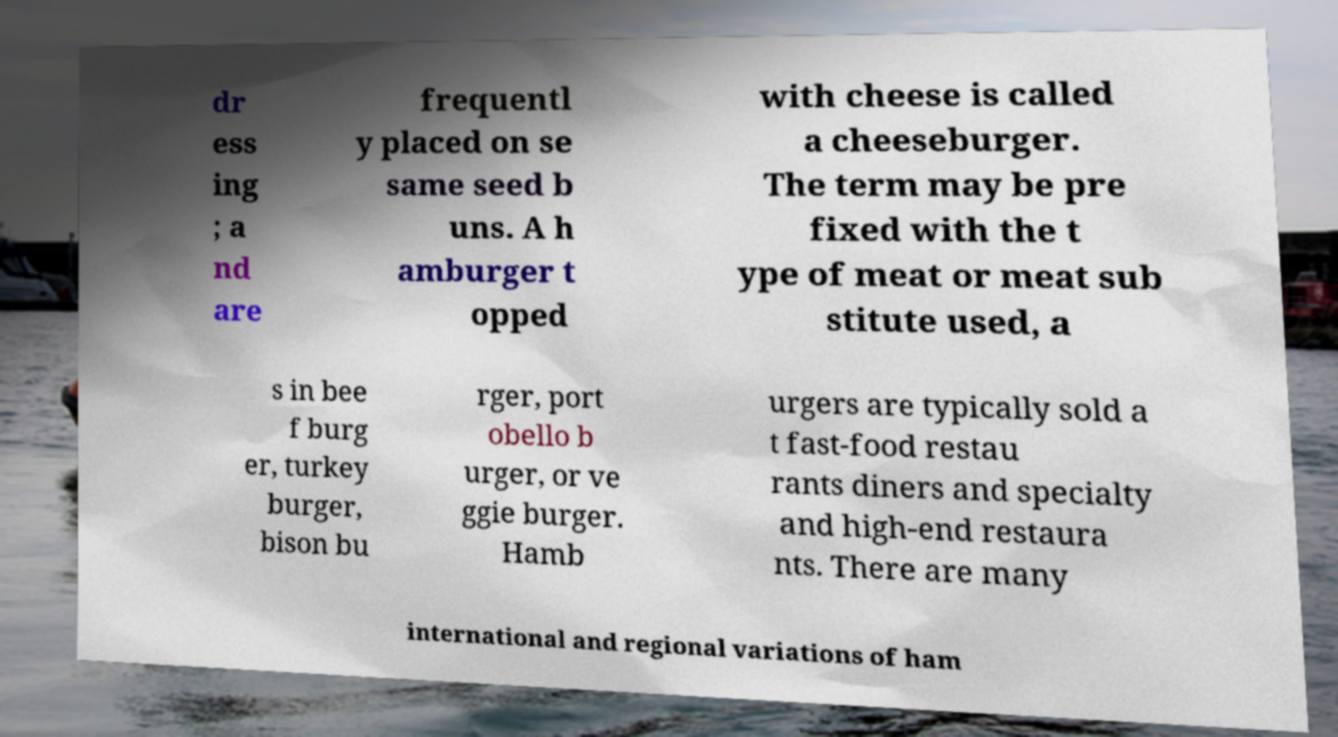I need the written content from this picture converted into text. Can you do that? dr ess ing ; a nd are frequentl y placed on se same seed b uns. A h amburger t opped with cheese is called a cheeseburger. The term may be pre fixed with the t ype of meat or meat sub stitute used, a s in bee f burg er, turkey burger, bison bu rger, port obello b urger, or ve ggie burger. Hamb urgers are typically sold a t fast-food restau rants diners and specialty and high-end restaura nts. There are many international and regional variations of ham 